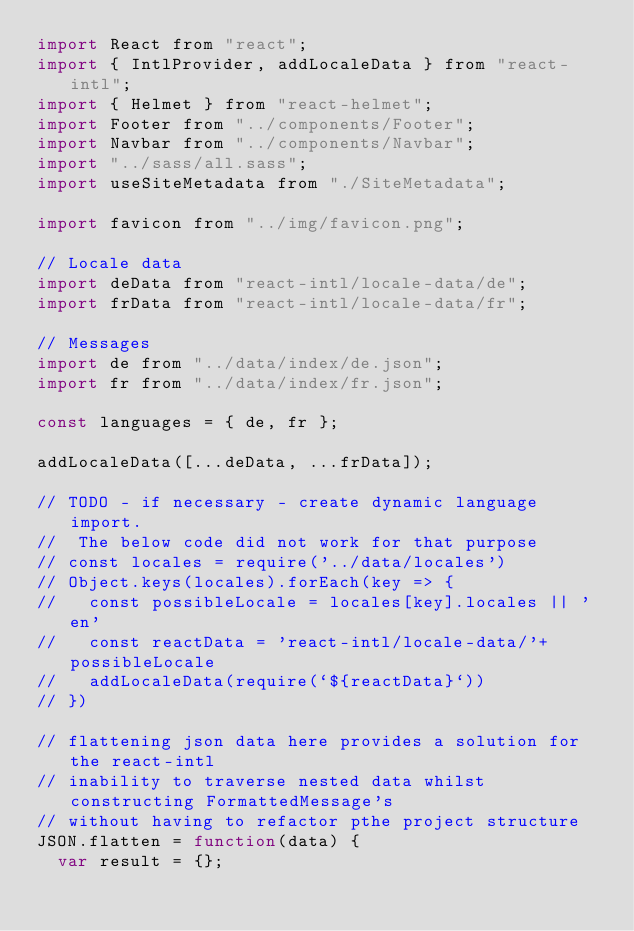<code> <loc_0><loc_0><loc_500><loc_500><_JavaScript_>import React from "react";
import { IntlProvider, addLocaleData } from "react-intl";
import { Helmet } from "react-helmet";
import Footer from "../components/Footer";
import Navbar from "../components/Navbar";
import "../sass/all.sass";
import useSiteMetadata from "./SiteMetadata";

import favicon from "../img/favicon.png";

// Locale data
import deData from "react-intl/locale-data/de";
import frData from "react-intl/locale-data/fr";

// Messages
import de from "../data/index/de.json";
import fr from "../data/index/fr.json";

const languages = { de, fr };

addLocaleData([...deData, ...frData]);

// TODO - if necessary - create dynamic language import.
//  The below code did not work for that purpose
// const locales = require('../data/locales')
// Object.keys(locales).forEach(key => {
//   const possibleLocale = locales[key].locales || 'en'
//   const reactData = 'react-intl/locale-data/'+possibleLocale
//   addLocaleData(require(`${reactData}`))
// })

// flattening json data here provides a solution for the react-intl
// inability to traverse nested data whilst constructing FormattedMessage's
// without having to refactor pthe project structure
JSON.flatten = function(data) {
  var result = {};
</code> 